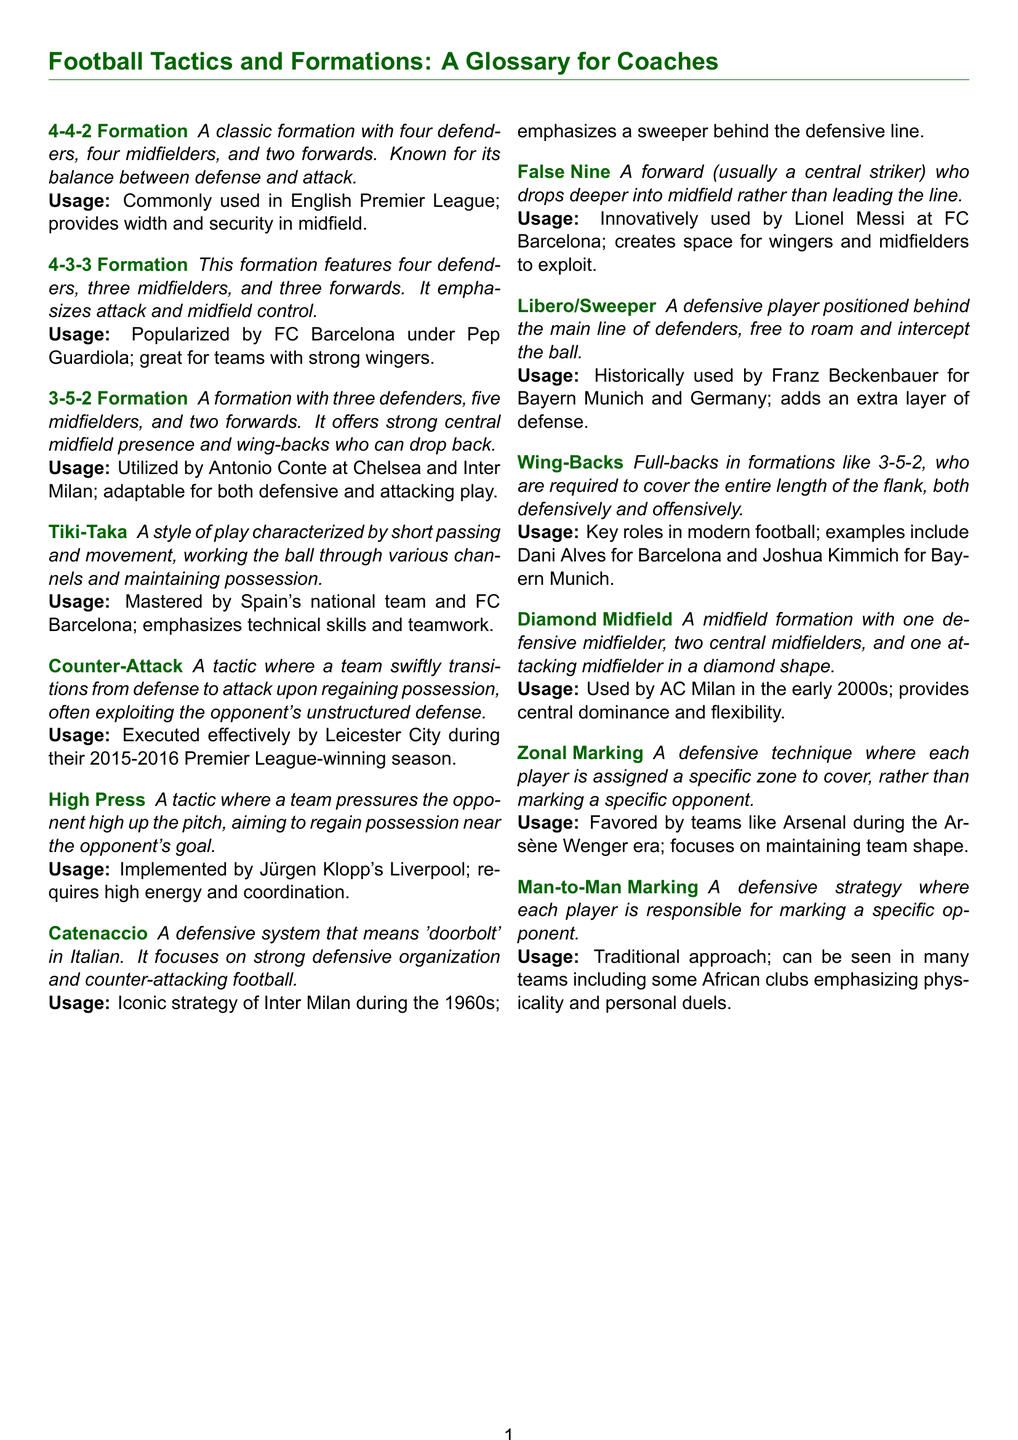What is the 4-4-2 Formation? The 4-4-2 Formation is defined as a classic formation with four defenders, four midfielders, and two forwards.
Answer: A classic formation with four defenders, four midfielders, and two forwards What team popularized the 4-3-3 Formation? The 4-3-3 Formation was popularized by FC Barcelona under Pep Guardiola.
Answer: FC Barcelona What is Tiki-Taka characterized by? Tiki-Taka is characterized by short passing and movement, working the ball through various channels and maintaining possession.
Answer: Short passing and movement Which formation uses wing-backs? The 3-5-2 Formation uses wing-backs who are required to cover the entire length of the flank.
Answer: 3-5-2 Formation What does Catenaccio mean in Italian? Catenaccio means "doorbolt" in Italian.
Answer: Doorbolt What type of marking does Zonal Marking refer to? Zonal Marking refers to a defensive technique where each player is assigned a specific zone to cover.
Answer: Defensive technique Who is the legendary player associated with the Libero/Sweeper role? Franz Beckenbauer is historically associated with the Libero/Sweeper role.
Answer: Franz Beckenbauer What is the main focus of the Counter-Attack tactic? The main focus of the Counter-Attack tactic is to swiftly transition from defense to attack.
Answer: Swift transition from defense to attack How many midfielders are in a Diamond Midfield? There are four midfielders in a Diamond Midfield setup.
Answer: Four midfielders 